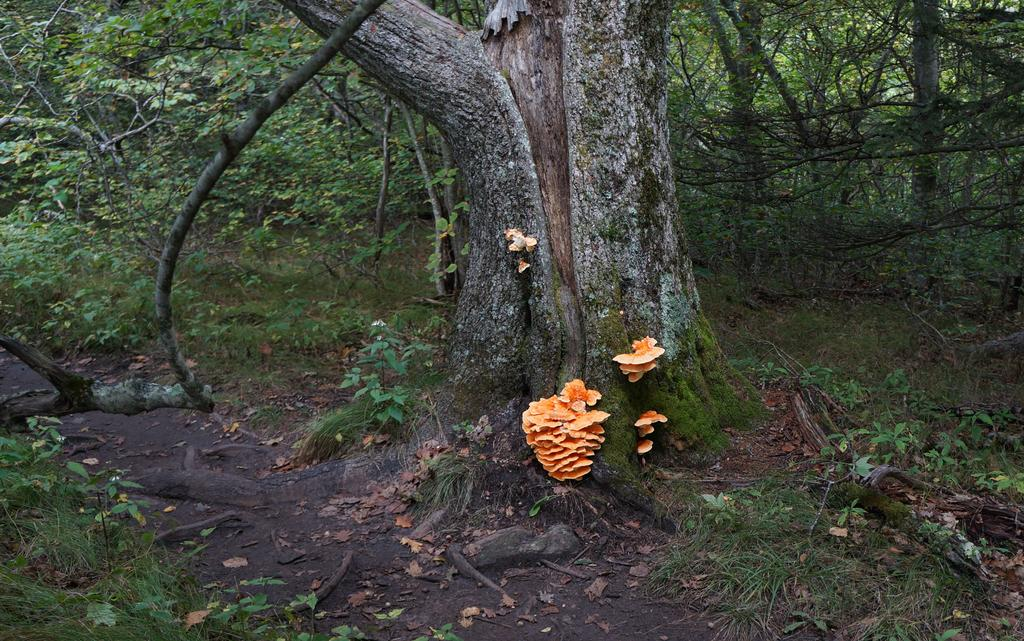What type of growth can be seen on the tree in the image? There is fungus mould on a tree in the image. What else can be seen on the tree in the image? There is algae on the stem of the tree in the image. What is the general theme of the image? The image contains many plants and trees. What type of bread is visible in the image? There is no bread, specifically a loaf, present in the image. 